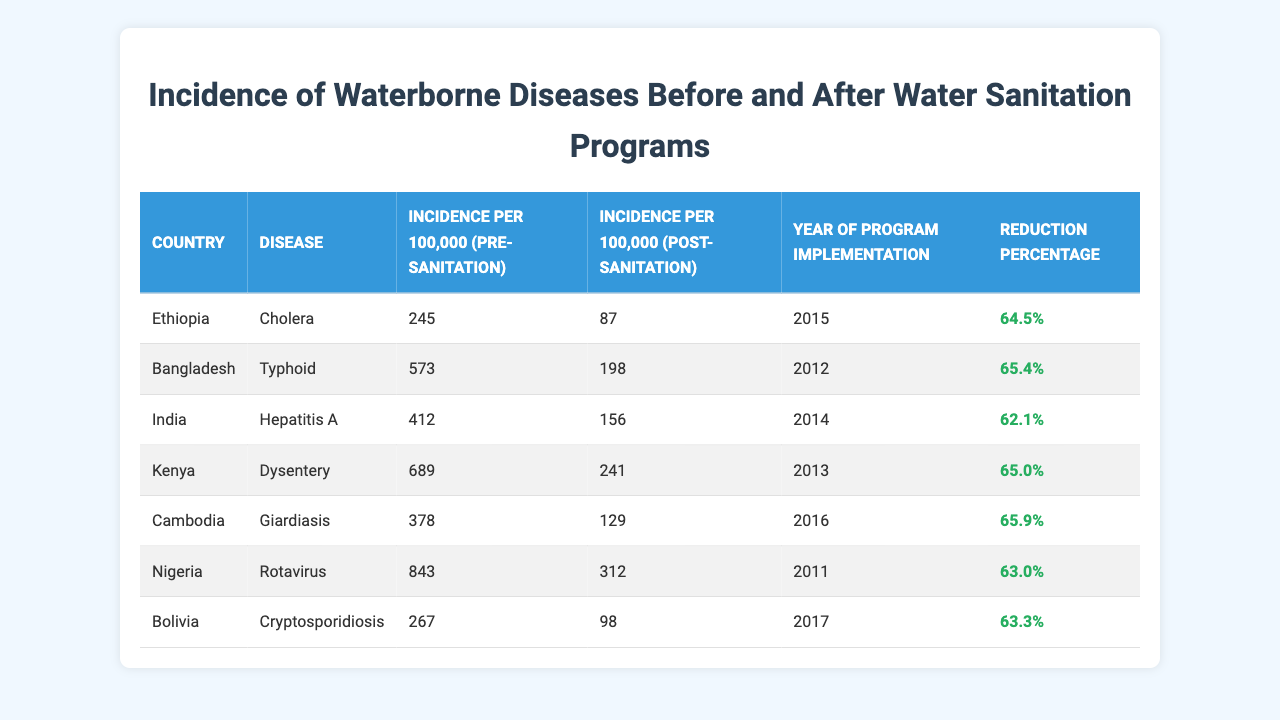What was the incidence of cholera in Ethiopia before the sanitation program? According to the table, the incidence of cholera in Ethiopia prior to the sanitation program was 245 per 100,000.
Answer: 245 Which country implemented a water sanitation program in 2012? The table lists Bangladesh as having implemented a water sanitation program in 2012.
Answer: Bangladesh What was the reduction percentage of typhoid cases in Bangladesh after the program? The table shows that the reduction percentage for typhoid cases in Bangladesh post-sanitation was 65.4%.
Answer: 65.4% Which disease in Kenya had the highest incidence per 100,000 before the sanitation program? Reviewing the data, dysentery was the disease with the highest incidence per 100,000 in Kenya, recorded at 689 before the sanitation program.
Answer: Dysentery Compare the post-sanitation incidence rates for cholera in Ethiopia and typhoid in Bangladesh. The post-sanitation incidence for cholera in Ethiopia is 87 per 100,000, while for typhoid in Bangladesh, it is 198 per 100,000. Therefore, cholera has a lower post-sanitation incidence rate than typhoid.
Answer: Cholera has a lower rate What is the average reduction percentage among the listed diseases? To find the average, sum all reduction percentages (64.5 + 65.4 + 62.1 + 65.0 + 65.9 + 63.0 + 63.3 = 415.2) and divide by the number of diseases (7). This gives an average of approximately 59.3%.
Answer: 59.3% Which disease had the lowest incidence per 100,000 post-sanitation among the countries listed? Reviewing the post-sanitation incidence rates in the table, cholera in Ethiopia had the lowest incidence at 87 per 100,000.
Answer: Cholera in Ethiopia Is it true that Nigeria's rotavirus incidence was higher than India's hepatitis A incidence before sanitation? Yes, the pre-sanitation incidence of rotavirus in Nigeria was 843 per 100,000, which is higher than hepatitis A in India, which was 412 per 100,000.
Answer: Yes What was the percentage reduction in incidence for Cryptosporidiosis in Bolivia? The table indicates a reduction percentage of 63.3% for Cryptosporidiosis in Bolivia after the sanitation program.
Answer: 63.3% Which country saw a reduction in hepatitis A incidence of 62.1% after the implementation of its program? India is listed in the table with a post-sanitation reduction of 62.1% for hepatitis A.
Answer: India What can be inferred about the effectiveness of water sanitation programs based on the data? Analyzing the table, we can infer that all listed countries experienced significant reductions in disease incidence, indicating that the water sanitation programs were generally effective.
Answer: They were effective 